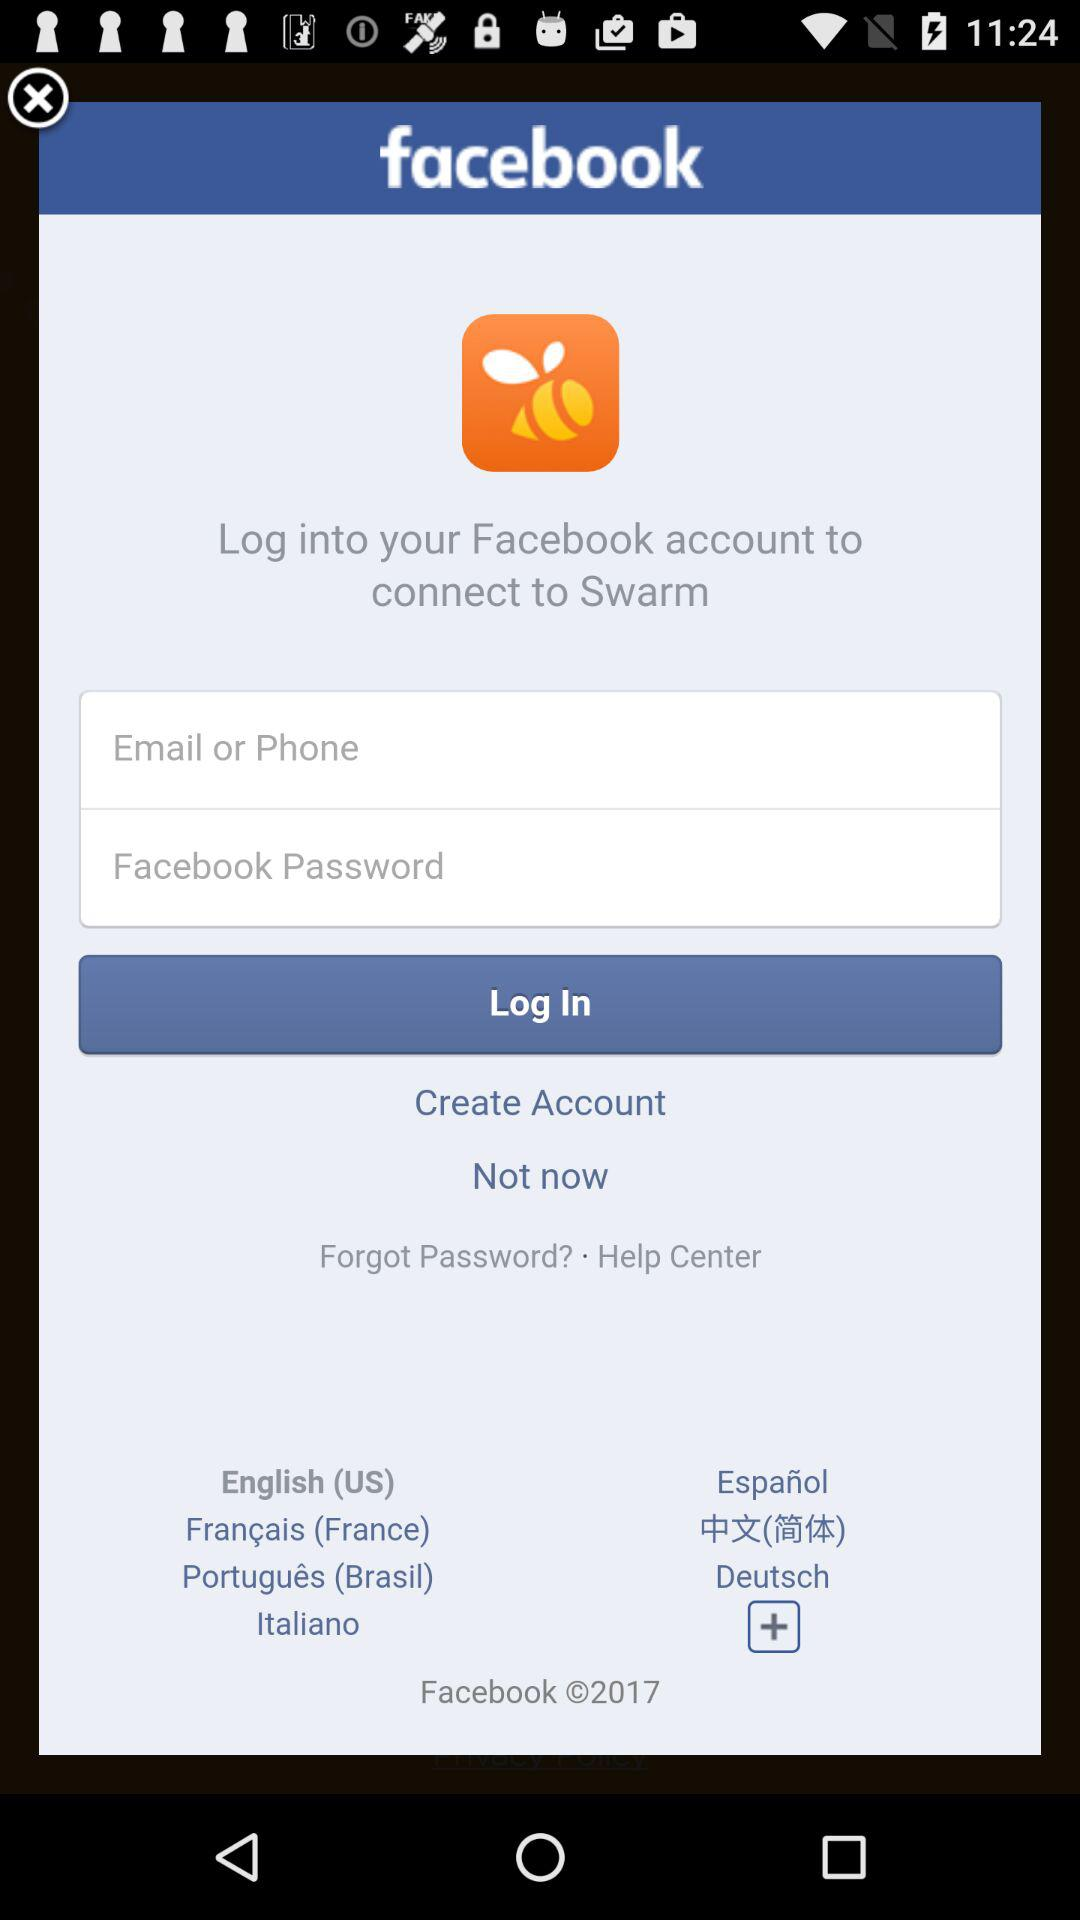How many fields are there in the login form?
Answer the question using a single word or phrase. 2 